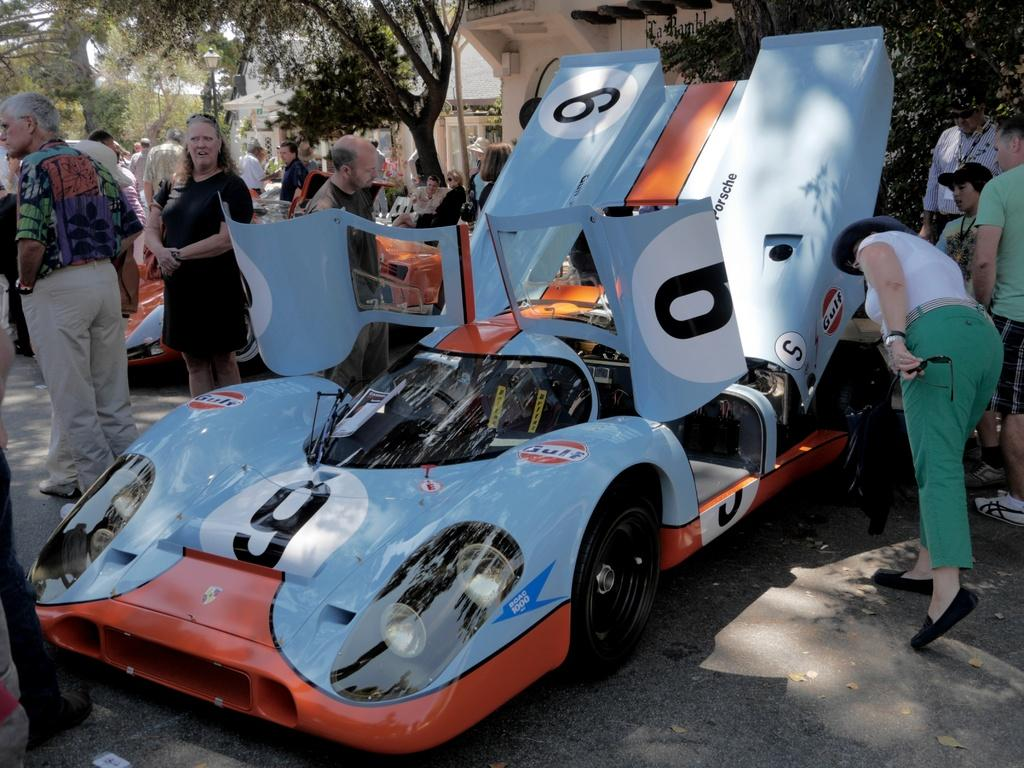What type of vehicles can be seen in the image? There are cars in the image. Who or what else is present in the image? There are persons in the image. What can be seen in the background of the image? There are buildings, trees, and a pole with a light visible in the background of the image. What part of the natural environment is visible in the image? The sky is visible in the top left corner of the image. What is the rate of water consumption by the zebra in the image? There is no zebra present in the image, so it is not possible to determine the rate of water consumption. 